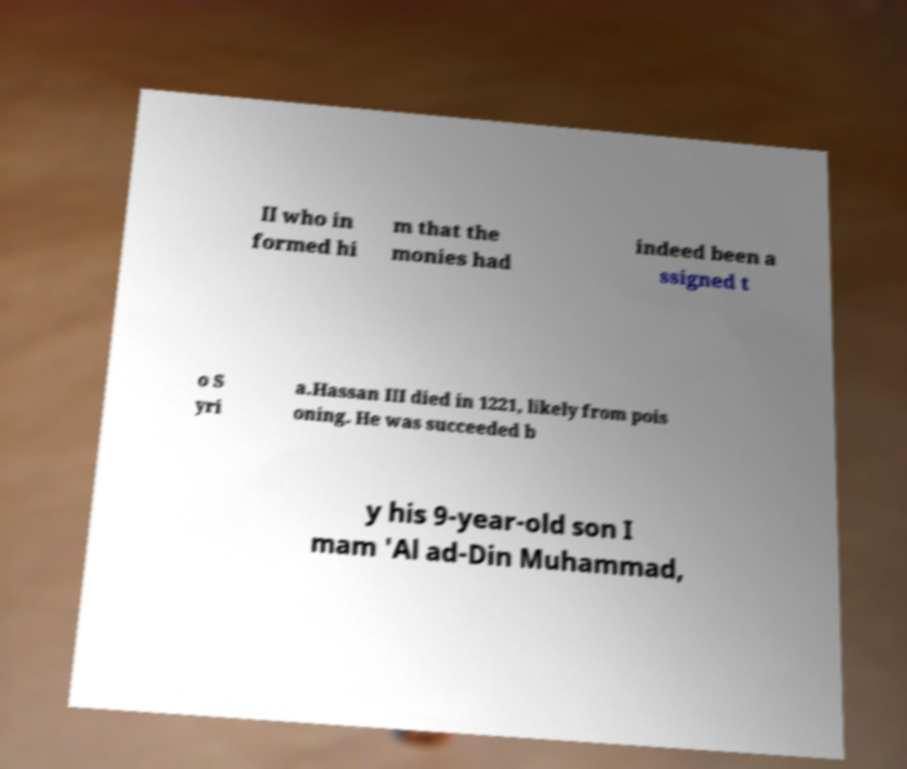Please read and relay the text visible in this image. What does it say? II who in formed hi m that the monies had indeed been a ssigned t o S yri a.Hassan III died in 1221, likely from pois oning. He was succeeded b y his 9-year-old son I mam 'Al ad-Din Muhammad, 